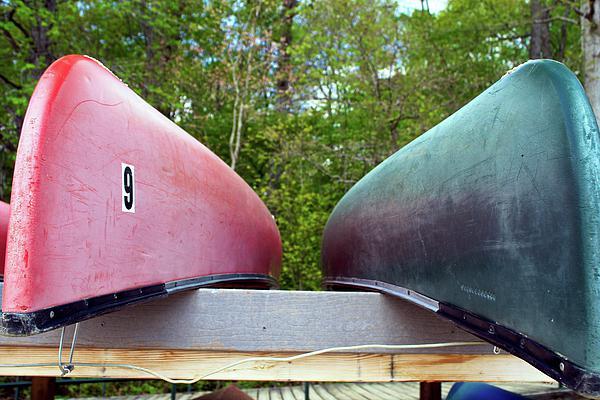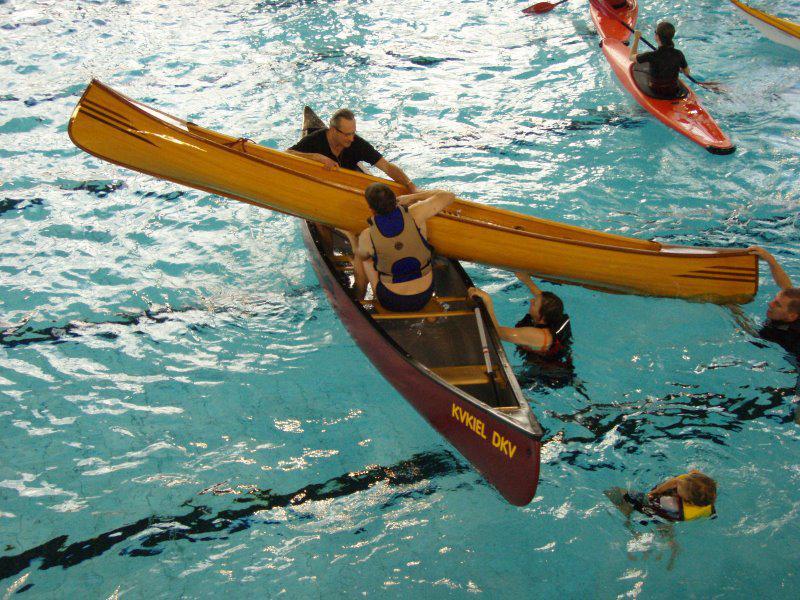The first image is the image on the left, the second image is the image on the right. Analyze the images presented: Is the assertion "At least one boat has at least one person sitting in it." valid? Answer yes or no. Yes. The first image is the image on the left, the second image is the image on the right. Evaluate the accuracy of this statement regarding the images: "Two canoes are upside down.". Is it true? Answer yes or no. Yes. 